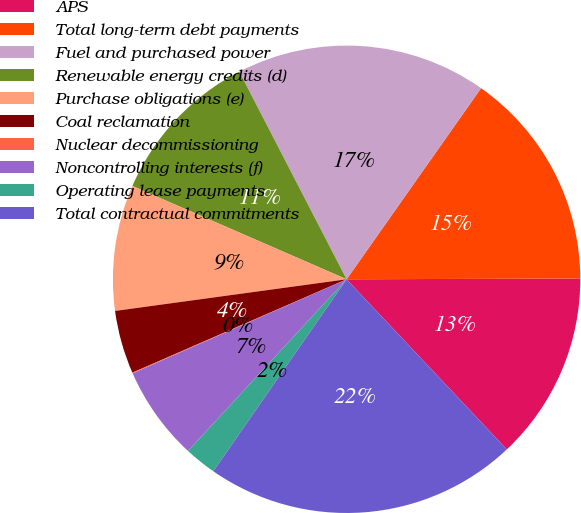Convert chart to OTSL. <chart><loc_0><loc_0><loc_500><loc_500><pie_chart><fcel>APS<fcel>Total long-term debt payments<fcel>Fuel and purchased power<fcel>Renewable energy credits (d)<fcel>Purchase obligations (e)<fcel>Coal reclamation<fcel>Nuclear decommissioning<fcel>Noncontrolling interests (f)<fcel>Operating lease payments<fcel>Total contractual commitments<nl><fcel>13.03%<fcel>15.19%<fcel>17.35%<fcel>10.87%<fcel>8.7%<fcel>4.38%<fcel>0.05%<fcel>6.54%<fcel>2.21%<fcel>21.68%<nl></chart> 